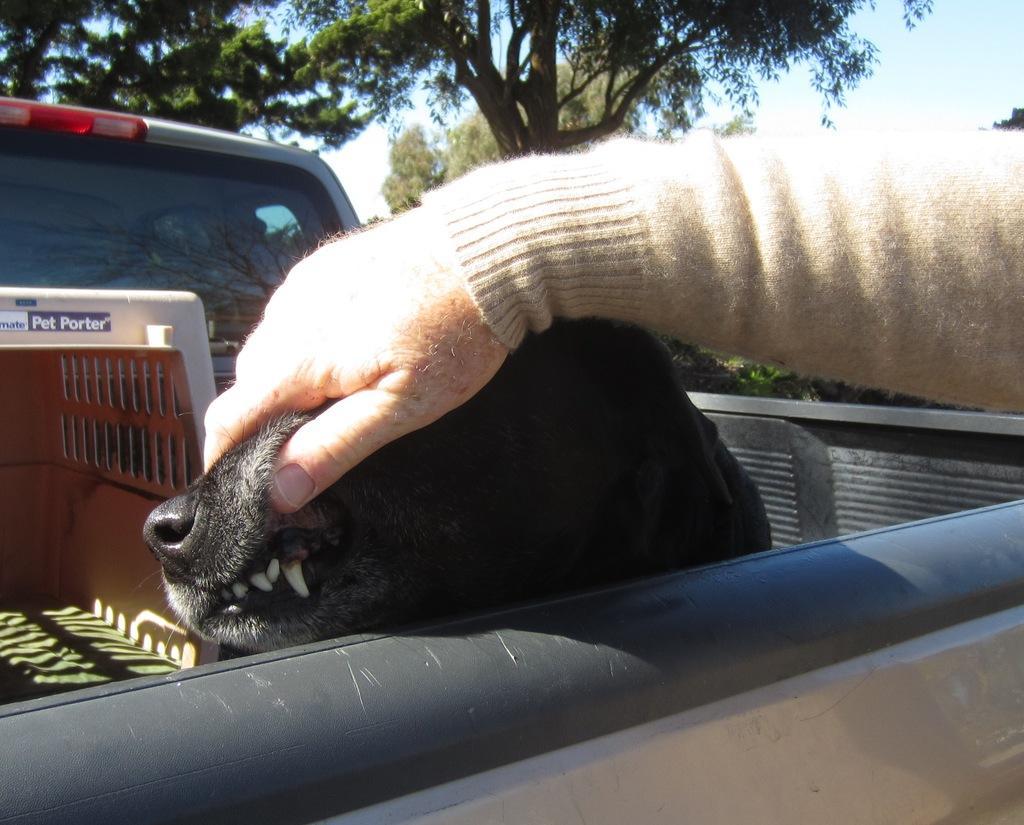Please provide a concise description of this image. In this picture there is a person holding the dog and there is a dog and there are objects in the vehicle. At the back there are trees. At the top there is sky. 